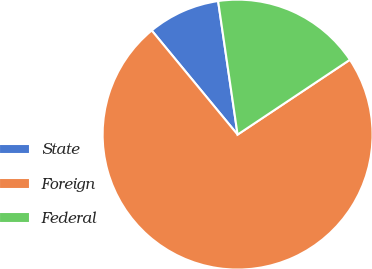<chart> <loc_0><loc_0><loc_500><loc_500><pie_chart><fcel>State<fcel>Foreign<fcel>Federal<nl><fcel>8.67%<fcel>73.38%<fcel>17.95%<nl></chart> 